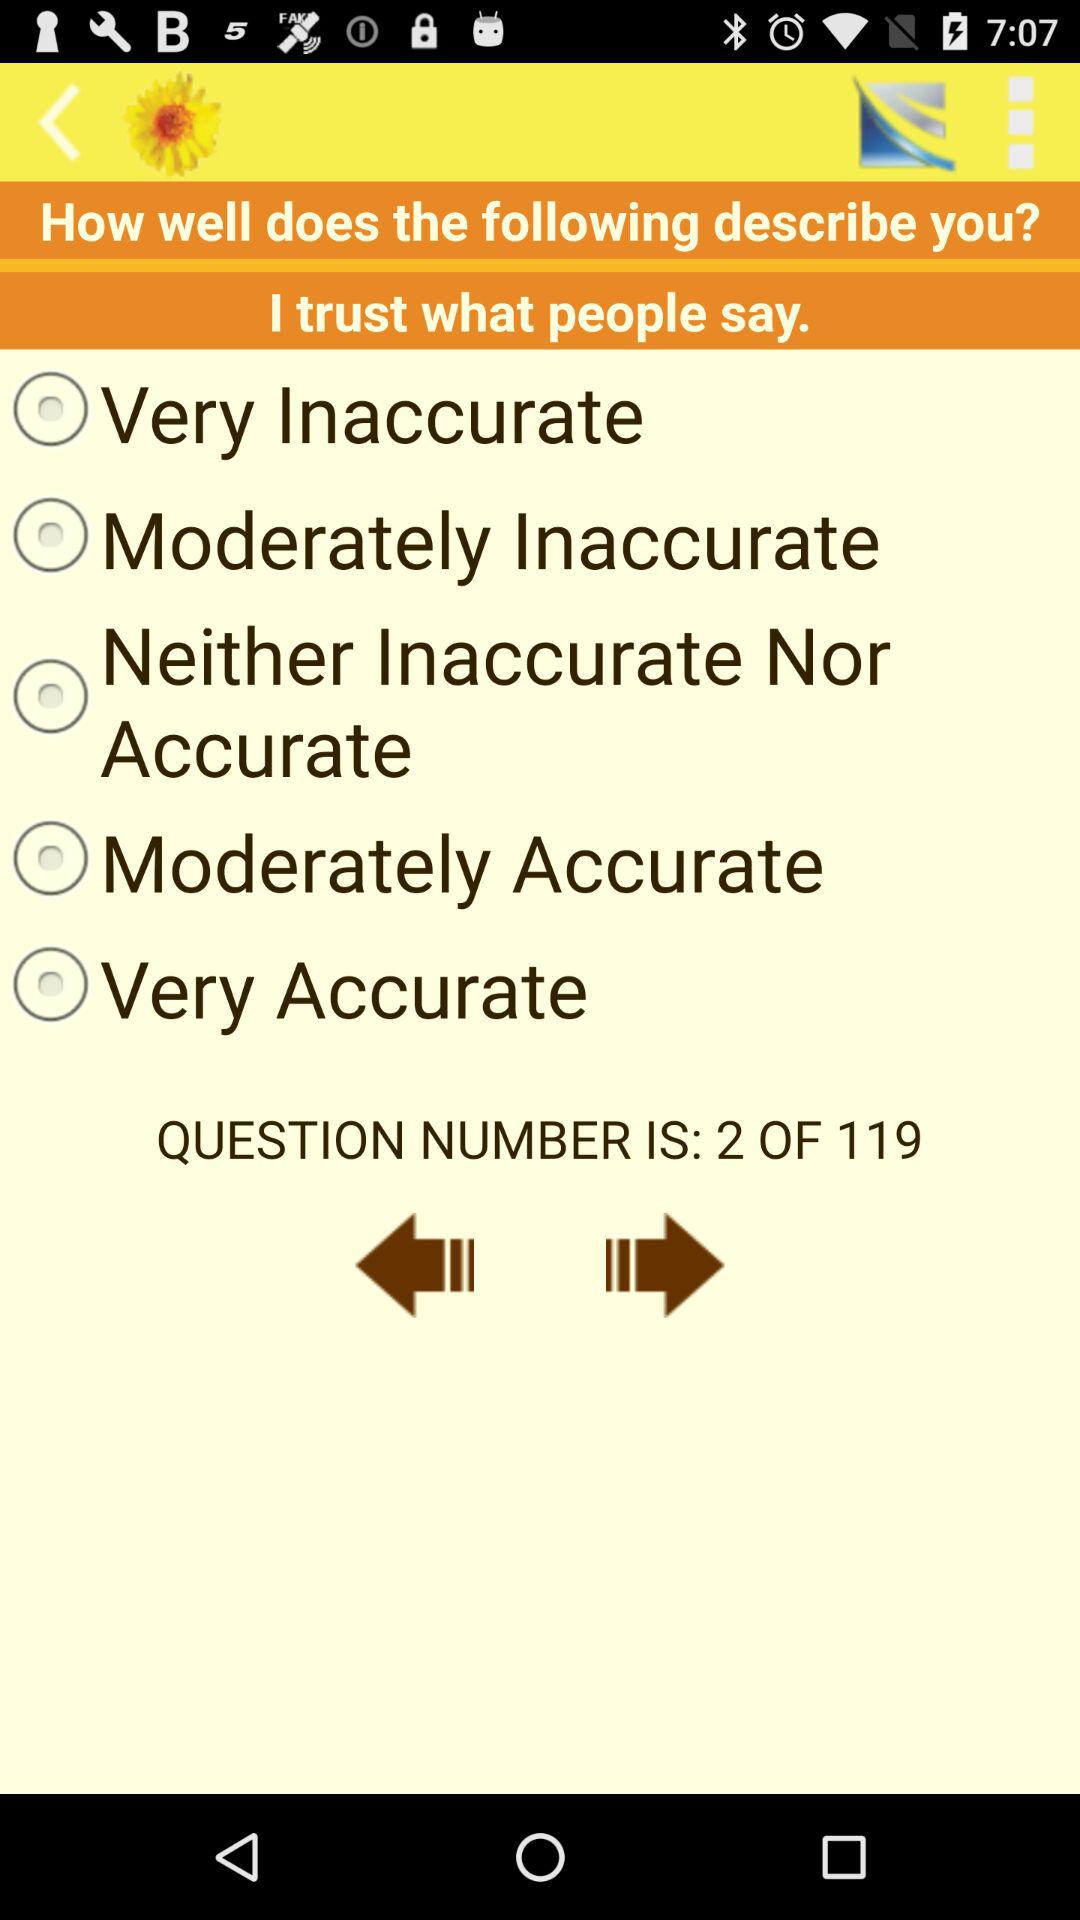What are the options available? The options available are "Very Inaccurate", "Moderately Inaccurate", "Neither Inaccurate Nor Accurate", "Moderately Accurate" and "Very Accurate". 